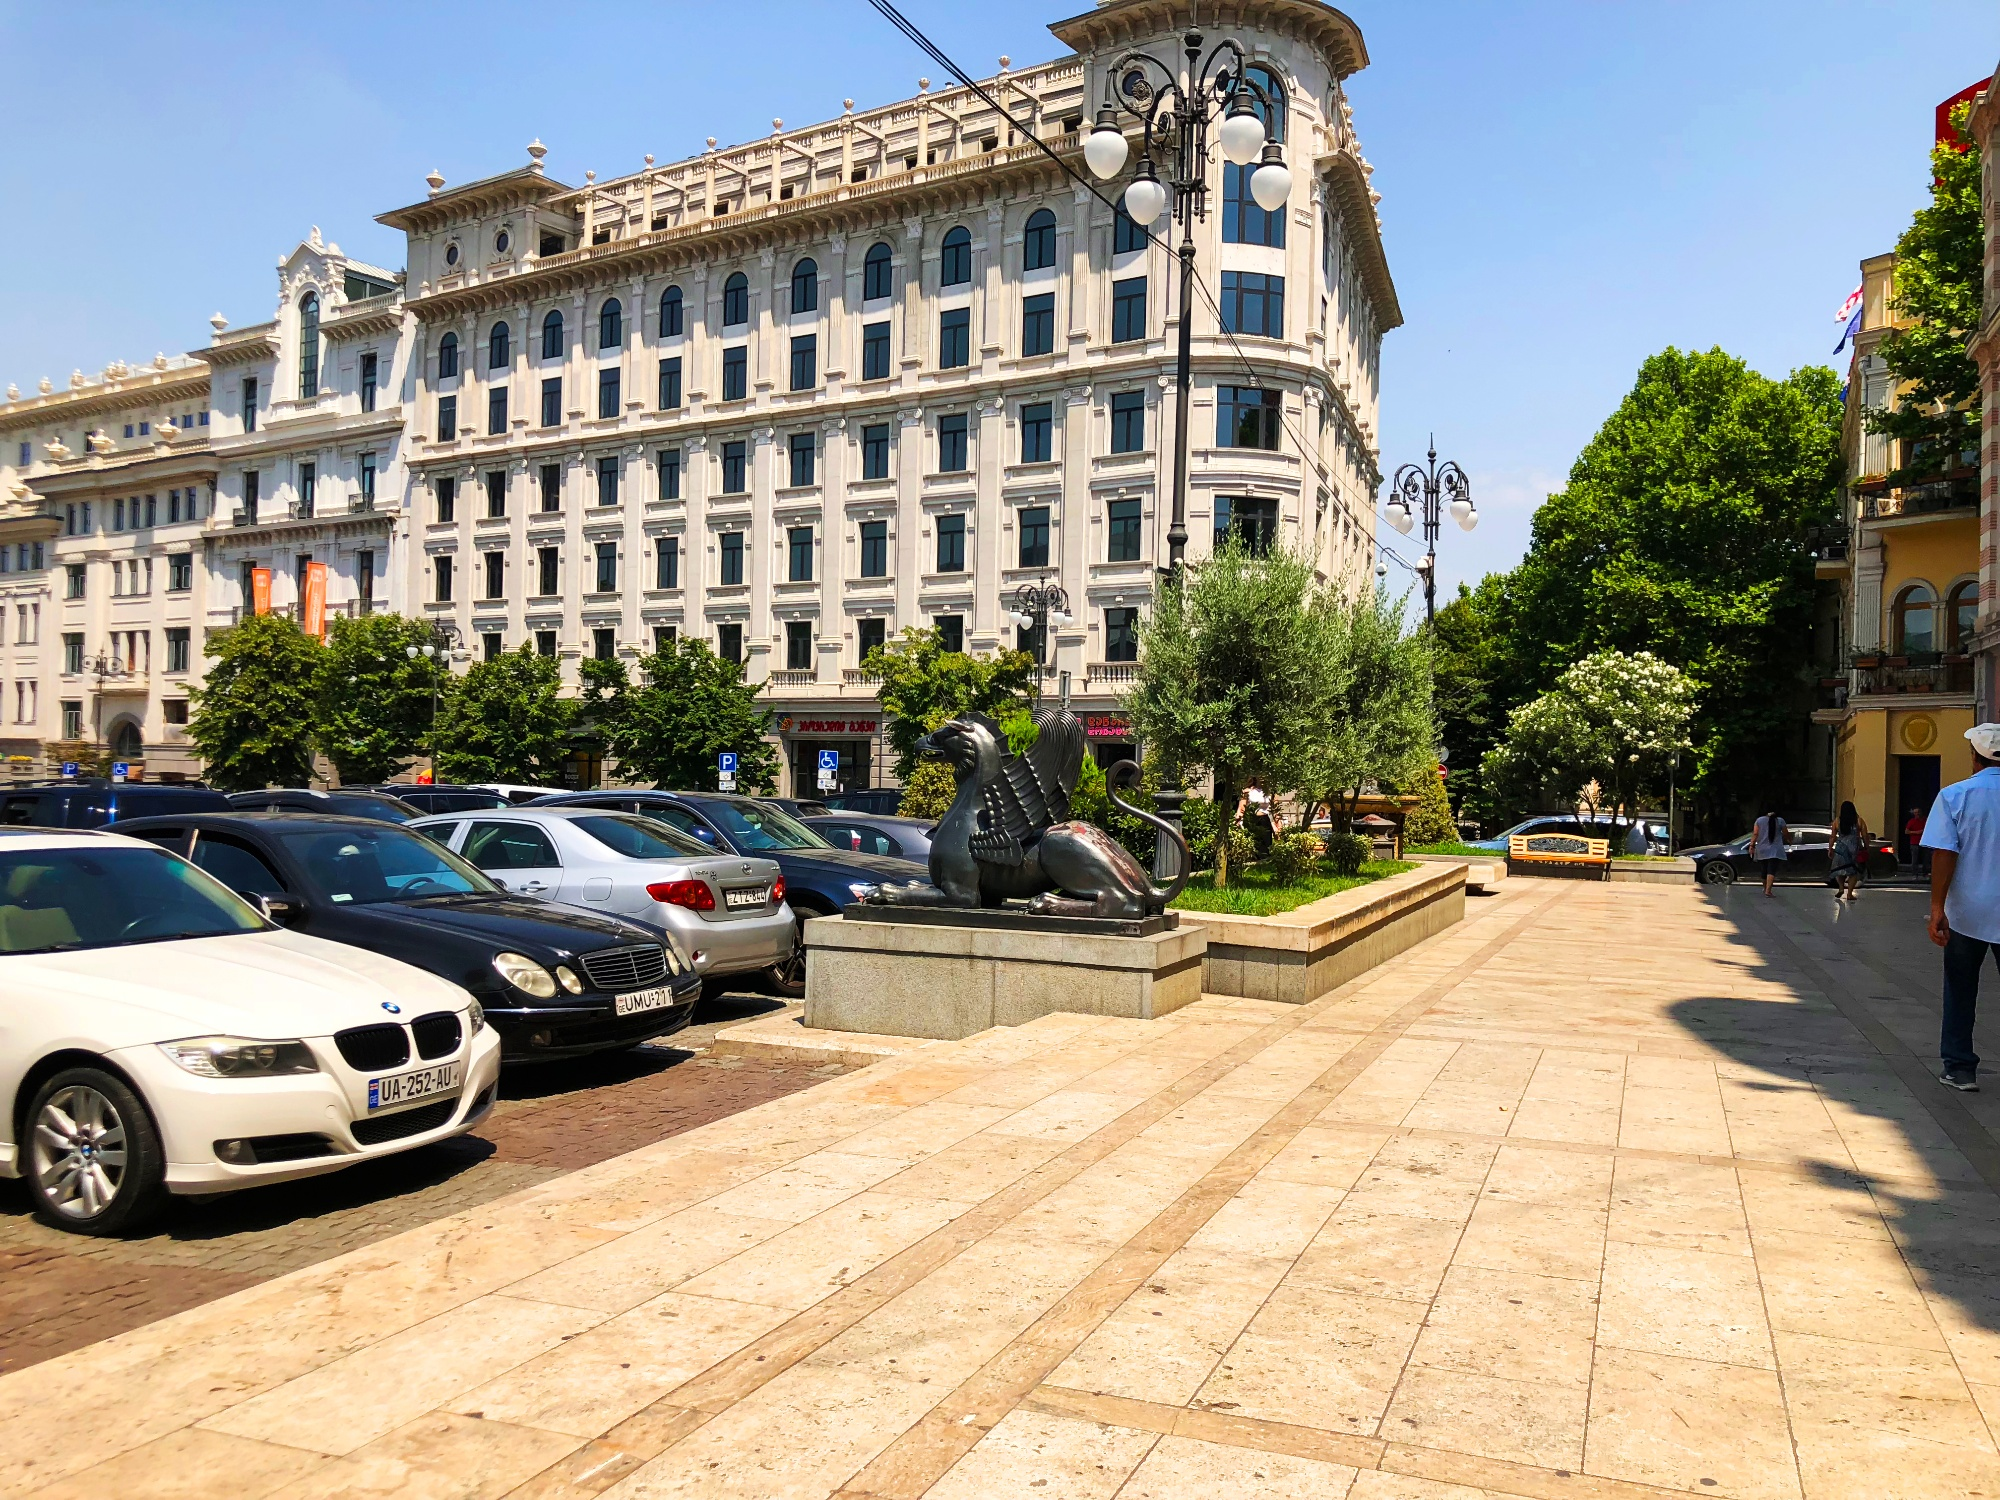What architectural style does the building in the image represent? The building's architectural style is representative of Beaux-Arts, which is characterized by grandiose and elaborate designs. It often features symmetrical shapes, rich detailing, and a mix of classical Greek and Roman influences, as evidenced by the ornate cornices, balustrades, and the use of pilasters along its façade. 